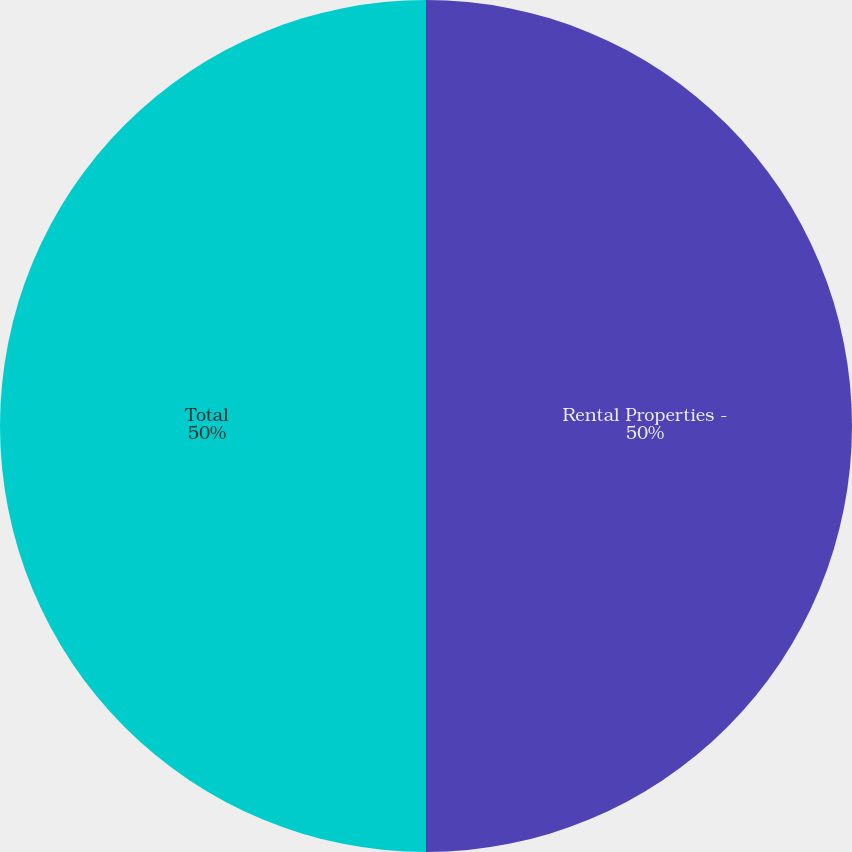Convert chart. <chart><loc_0><loc_0><loc_500><loc_500><pie_chart><fcel>Rental Properties -<fcel>Total<nl><fcel>50.0%<fcel>50.0%<nl></chart> 